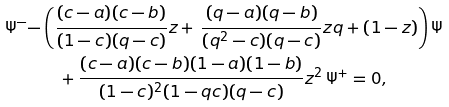Convert formula to latex. <formula><loc_0><loc_0><loc_500><loc_500>\Psi ^ { - } - & \left ( \frac { ( c - a ) ( c - b ) } { ( 1 - c ) ( q - c ) } z + \, \frac { ( q - a ) ( q - b ) } { ( q ^ { 2 } - c ) ( q - c ) } z q + ( 1 - z ) \right ) \Psi \\ & \quad + \frac { ( c - a ) ( c - b ) ( 1 - a ) ( 1 - b ) } { ( 1 - c ) ^ { 2 } ( 1 - q c ) ( q - c ) } z ^ { 2 } \, \Psi ^ { + } = 0 ,</formula> 